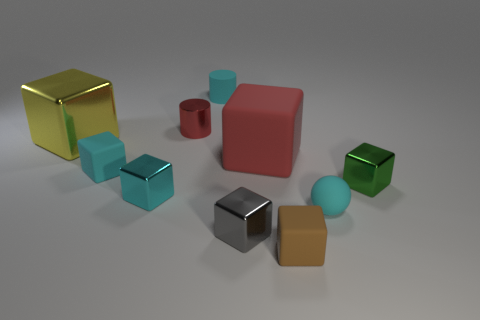Subtract all tiny green cubes. How many cubes are left? 6 Subtract 1 cylinders. How many cylinders are left? 1 Subtract all blue balls. How many cyan blocks are left? 2 Add 2 big purple metal cylinders. How many big purple metal cylinders exist? 2 Subtract all green blocks. How many blocks are left? 6 Subtract 0 red spheres. How many objects are left? 10 Subtract all cylinders. How many objects are left? 8 Subtract all brown blocks. Subtract all cyan cylinders. How many blocks are left? 6 Subtract all small cyan spheres. Subtract all blue cylinders. How many objects are left? 9 Add 5 small gray shiny things. How many small gray shiny things are left? 6 